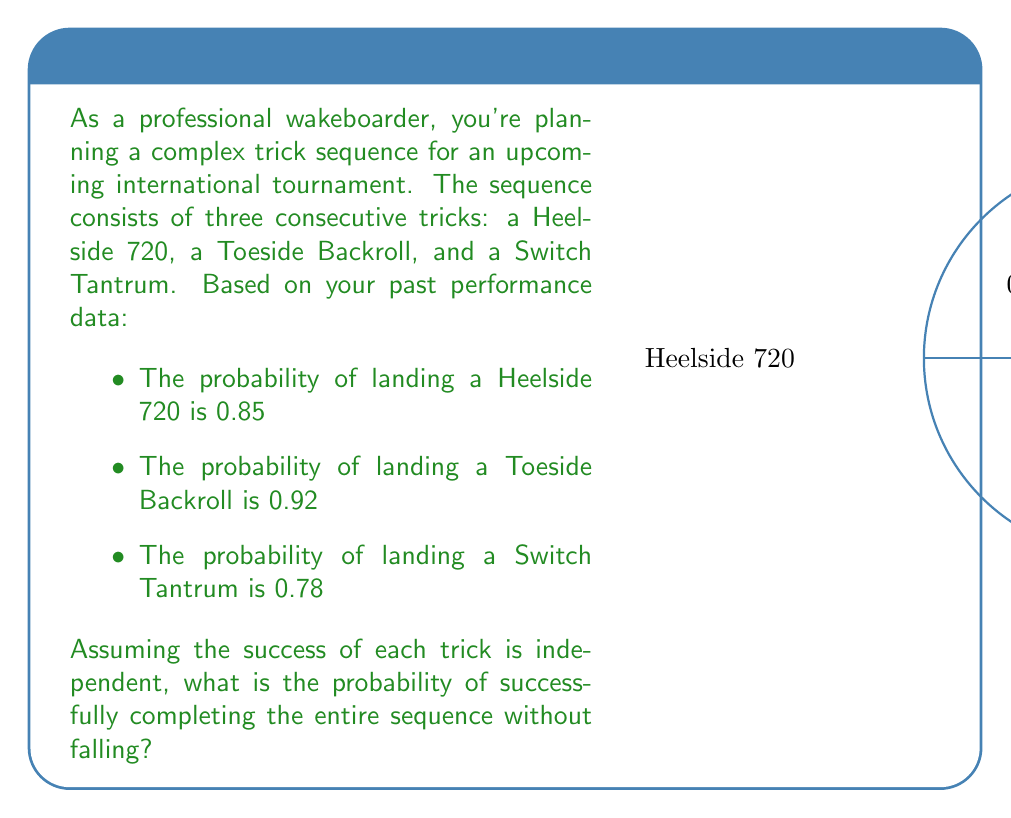Could you help me with this problem? To solve this problem, we'll use the multiplication rule of probability for independent events. The probability of all events occurring together is the product of their individual probabilities.

Let's break it down step-by-step:

1) Let A = probability of landing Heelside 720
   B = probability of landing Toeside Backroll
   C = probability of landing Switch Tantrum

2) Given:
   P(A) = 0.85
   P(B) = 0.92
   P(C) = 0.78

3) We want to find P(A and B and C), which is equivalent to P(A) × P(B) × P(C) for independent events.

4) Calculating:
   $$P(\text{entire sequence}) = P(A) \times P(B) \times P(C)$$
   $$= 0.85 \times 0.92 \times 0.78$$

5) Using a calculator or computing by hand:
   $$= 0.6095400$$

6) Rounding to four decimal places:
   $$= 0.6095$$

Therefore, the probability of successfully completing the entire sequence without falling is approximately 0.6095 or 60.95%.
Answer: 0.6095 